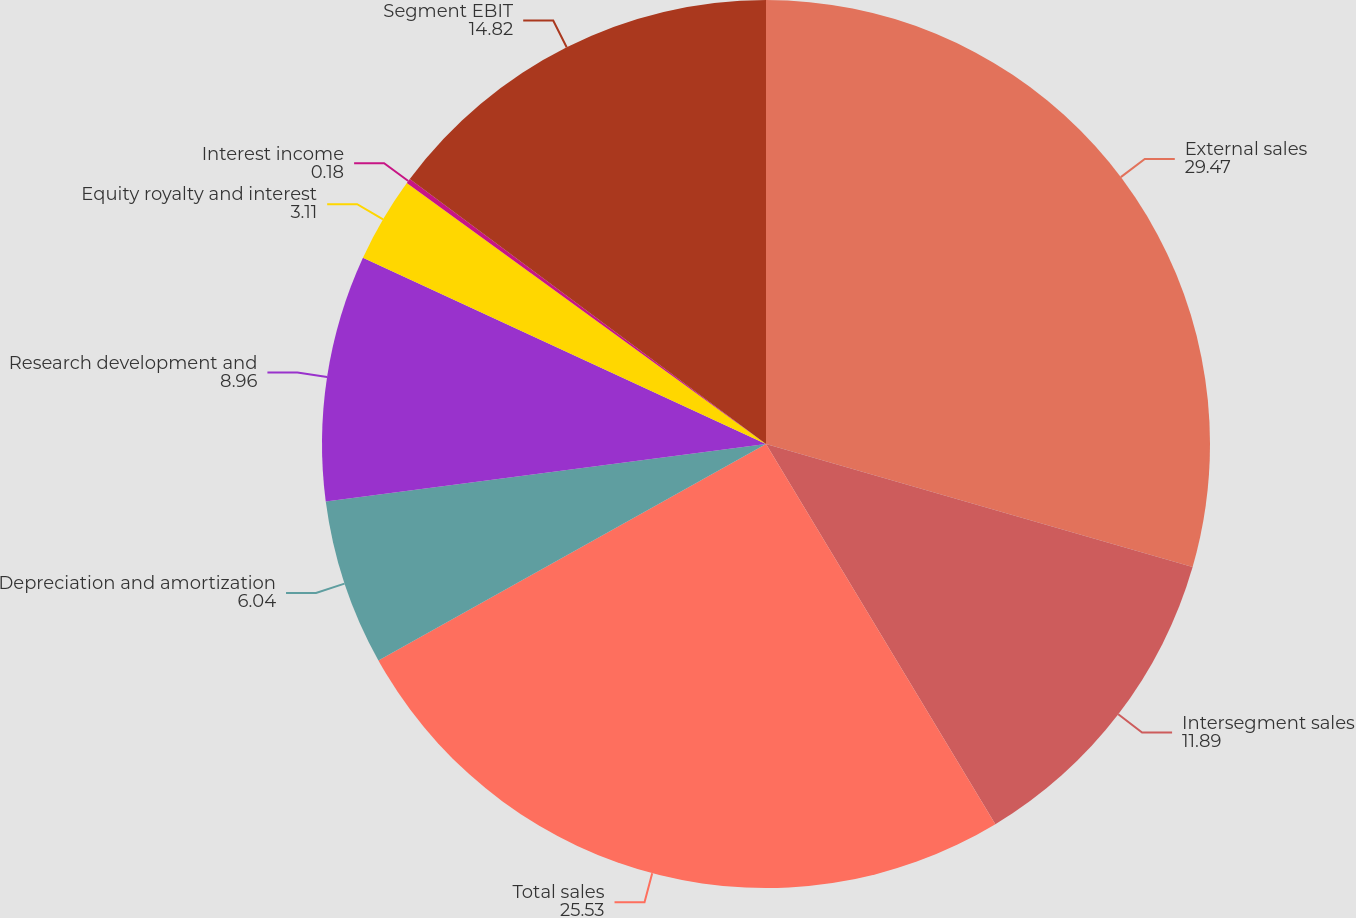Convert chart. <chart><loc_0><loc_0><loc_500><loc_500><pie_chart><fcel>External sales<fcel>Intersegment sales<fcel>Total sales<fcel>Depreciation and amortization<fcel>Research development and<fcel>Equity royalty and interest<fcel>Interest income<fcel>Segment EBIT<nl><fcel>29.47%<fcel>11.89%<fcel>25.53%<fcel>6.04%<fcel>8.96%<fcel>3.11%<fcel>0.18%<fcel>14.82%<nl></chart> 